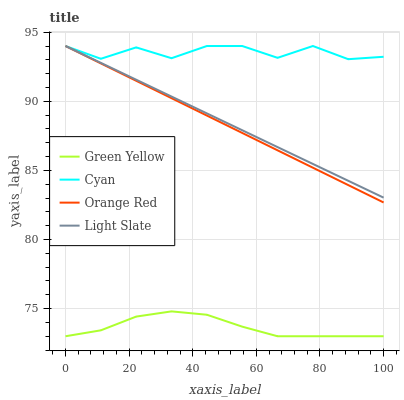Does Green Yellow have the minimum area under the curve?
Answer yes or no. Yes. Does Cyan have the maximum area under the curve?
Answer yes or no. Yes. Does Cyan have the minimum area under the curve?
Answer yes or no. No. Does Green Yellow have the maximum area under the curve?
Answer yes or no. No. Is Light Slate the smoothest?
Answer yes or no. Yes. Is Cyan the roughest?
Answer yes or no. Yes. Is Green Yellow the smoothest?
Answer yes or no. No. Is Green Yellow the roughest?
Answer yes or no. No. Does Green Yellow have the lowest value?
Answer yes or no. Yes. Does Cyan have the lowest value?
Answer yes or no. No. Does Orange Red have the highest value?
Answer yes or no. Yes. Does Green Yellow have the highest value?
Answer yes or no. No. Is Green Yellow less than Light Slate?
Answer yes or no. Yes. Is Cyan greater than Green Yellow?
Answer yes or no. Yes. Does Orange Red intersect Cyan?
Answer yes or no. Yes. Is Orange Red less than Cyan?
Answer yes or no. No. Is Orange Red greater than Cyan?
Answer yes or no. No. Does Green Yellow intersect Light Slate?
Answer yes or no. No. 